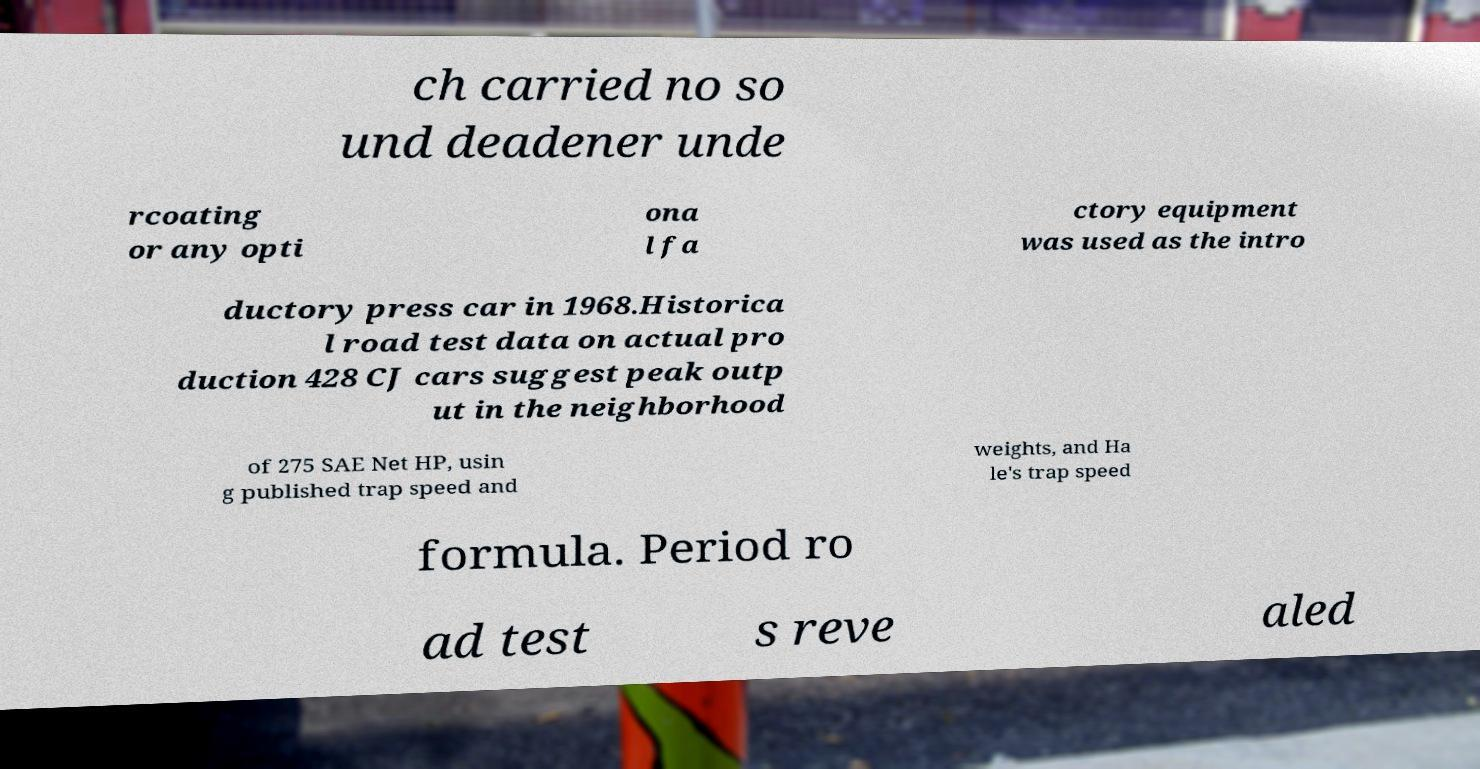Please read and relay the text visible in this image. What does it say? ch carried no so und deadener unde rcoating or any opti ona l fa ctory equipment was used as the intro ductory press car in 1968.Historica l road test data on actual pro duction 428 CJ cars suggest peak outp ut in the neighborhood of 275 SAE Net HP, usin g published trap speed and weights, and Ha le's trap speed formula. Period ro ad test s reve aled 